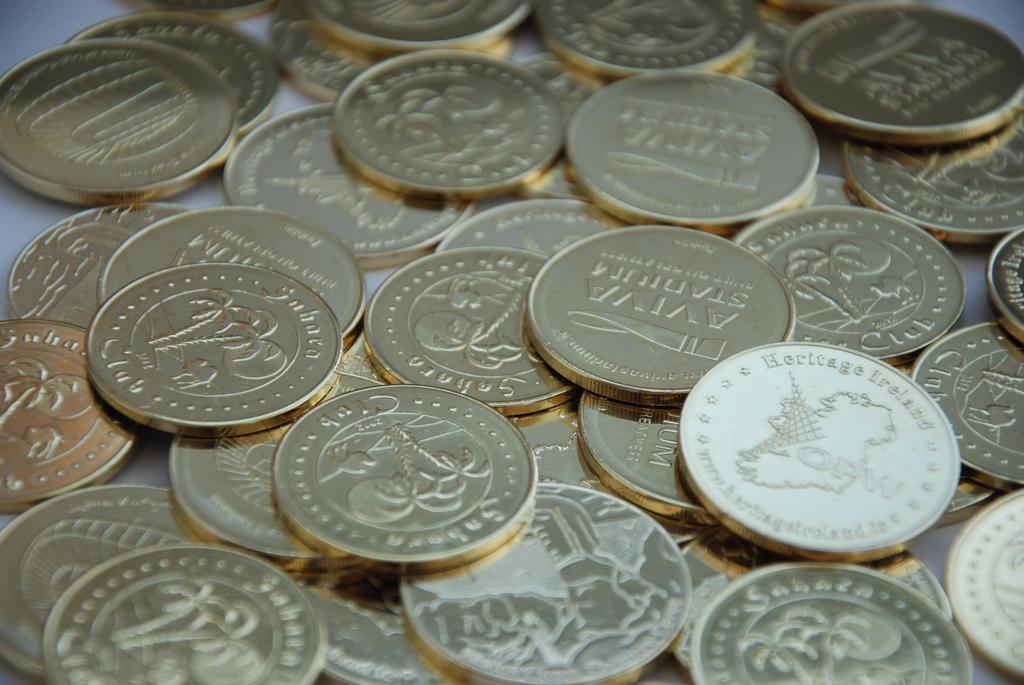<image>
Relay a brief, clear account of the picture shown. Many gold coins on a table with some saying "Aviva Stadium" on it. 